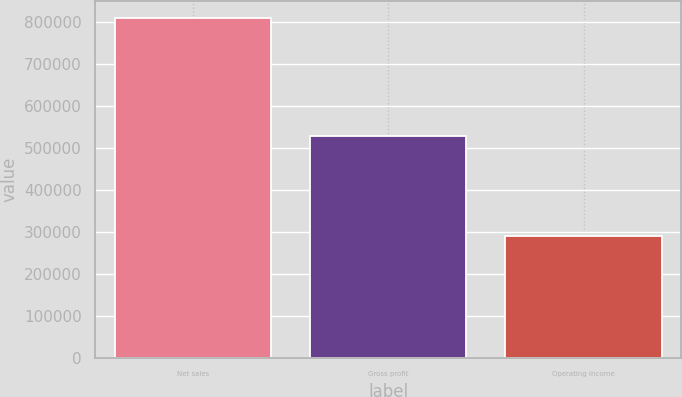Convert chart to OTSL. <chart><loc_0><loc_0><loc_500><loc_500><bar_chart><fcel>Net sales<fcel>Gross profit<fcel>Operating income<nl><fcel>809883<fcel>528254<fcel>290510<nl></chart> 